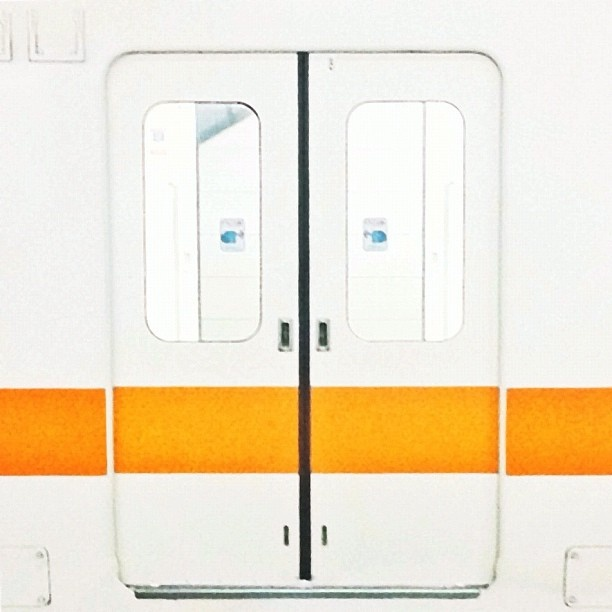Describe the objects in this image and their specific colors. I can see a train in white, orange, darkgray, and black tones in this image. 